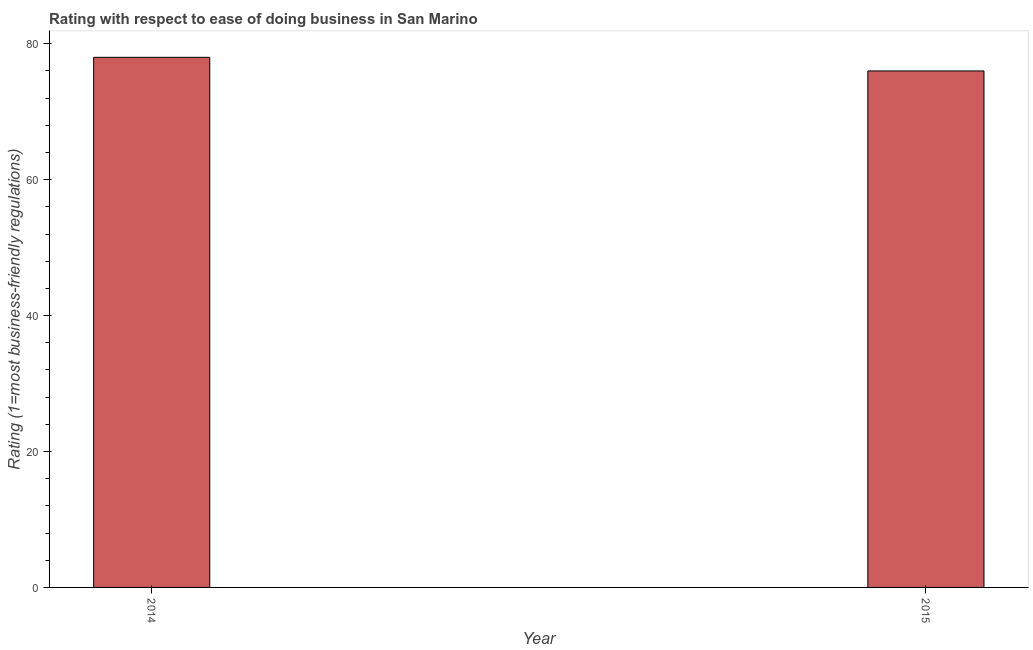What is the title of the graph?
Provide a short and direct response. Rating with respect to ease of doing business in San Marino. What is the label or title of the X-axis?
Offer a very short reply. Year. What is the label or title of the Y-axis?
Ensure brevity in your answer.  Rating (1=most business-friendly regulations). What is the ease of doing business index in 2015?
Your response must be concise. 76. In which year was the ease of doing business index minimum?
Your answer should be compact. 2015. What is the sum of the ease of doing business index?
Offer a terse response. 154. What is the difference between the ease of doing business index in 2014 and 2015?
Keep it short and to the point. 2. Do a majority of the years between 2015 and 2014 (inclusive) have ease of doing business index greater than 8 ?
Provide a short and direct response. No. In how many years, is the ease of doing business index greater than the average ease of doing business index taken over all years?
Make the answer very short. 1. Are all the bars in the graph horizontal?
Your answer should be very brief. No. Are the values on the major ticks of Y-axis written in scientific E-notation?
Ensure brevity in your answer.  No. What is the Rating (1=most business-friendly regulations) in 2014?
Provide a short and direct response. 78. What is the difference between the Rating (1=most business-friendly regulations) in 2014 and 2015?
Provide a short and direct response. 2. What is the ratio of the Rating (1=most business-friendly regulations) in 2014 to that in 2015?
Offer a terse response. 1.03. 